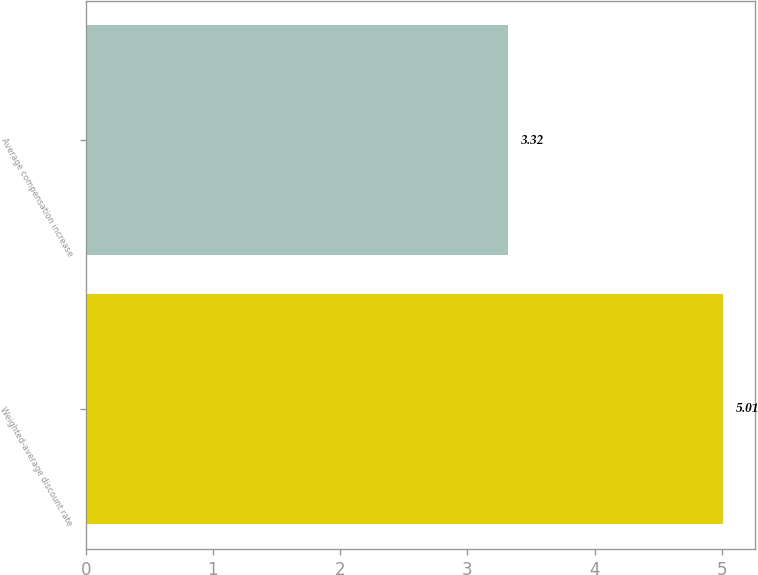<chart> <loc_0><loc_0><loc_500><loc_500><bar_chart><fcel>Weighted-average discount rate<fcel>Average compensation increase<nl><fcel>5.01<fcel>3.32<nl></chart> 